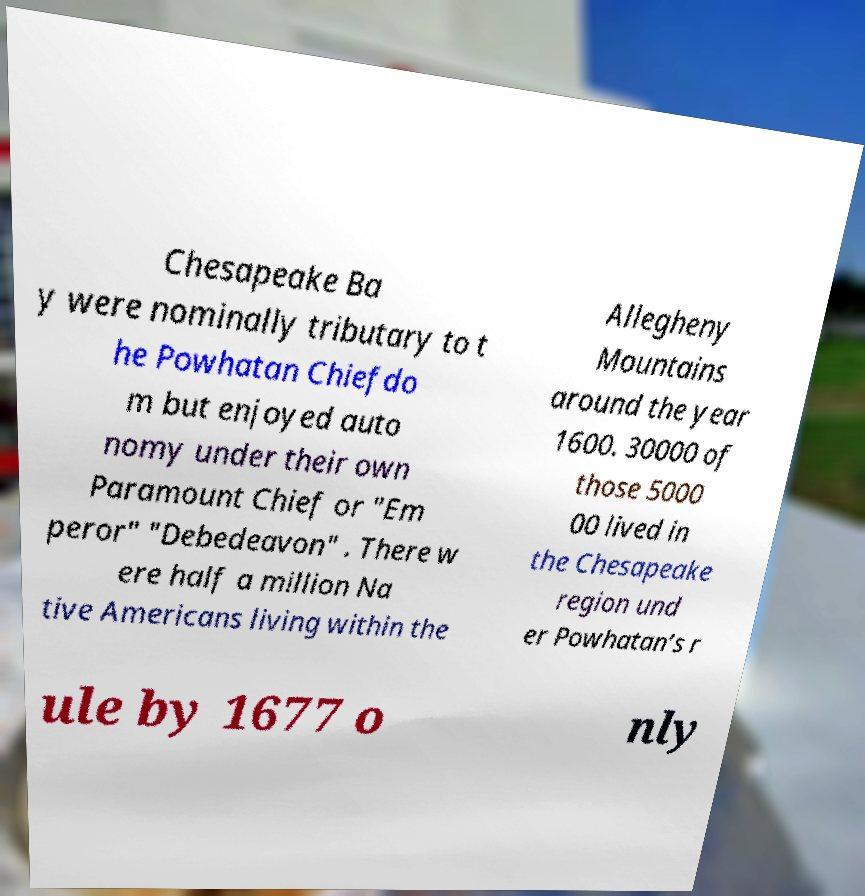Could you extract and type out the text from this image? Chesapeake Ba y were nominally tributary to t he Powhatan Chiefdo m but enjoyed auto nomy under their own Paramount Chief or "Em peror" "Debedeavon" . There w ere half a million Na tive Americans living within the Allegheny Mountains around the year 1600. 30000 of those 5000 00 lived in the Chesapeake region und er Powhatan’s r ule by 1677 o nly 